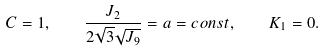Convert formula to latex. <formula><loc_0><loc_0><loc_500><loc_500>C = 1 , \quad \frac { J _ { 2 } } { 2 \sqrt { 3 } \sqrt { J _ { 9 } } } = a = c o n s t , \quad K _ { 1 } = 0 .</formula> 